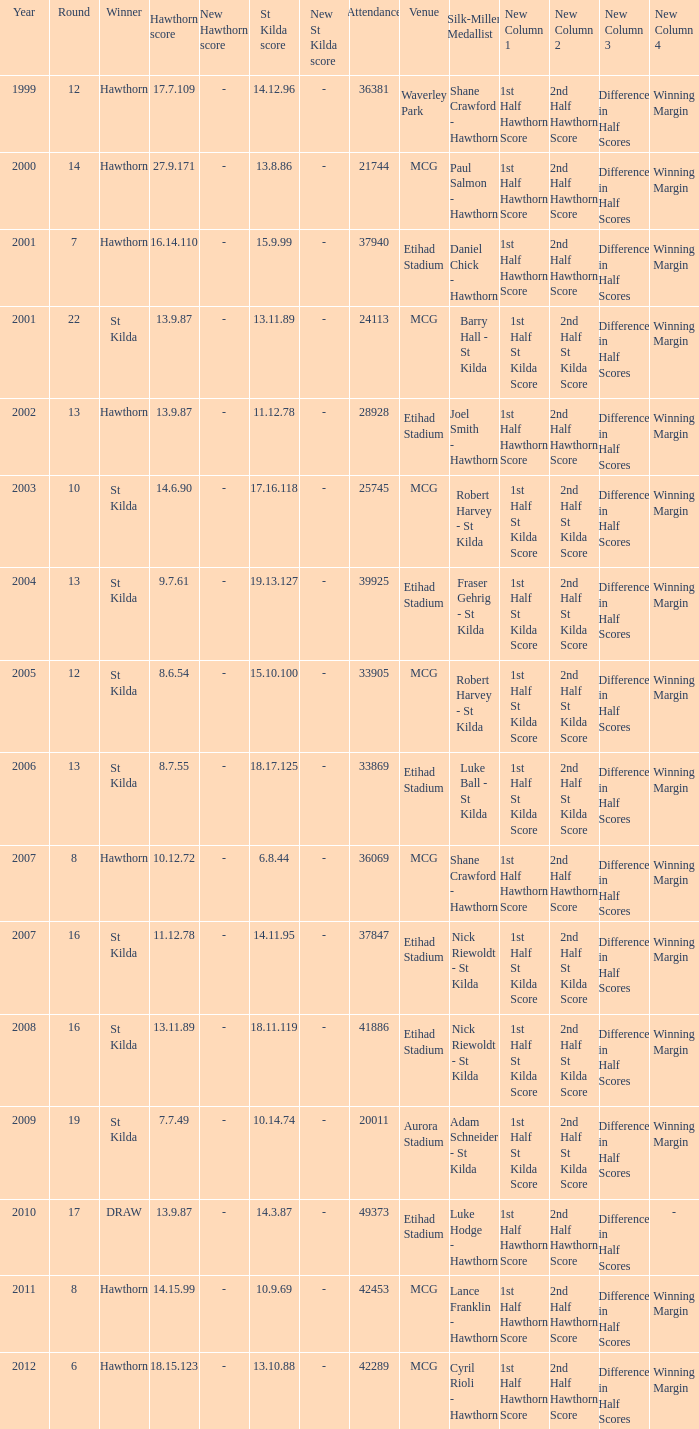How many winners have st kilda score at 14.11.95? 1.0. 